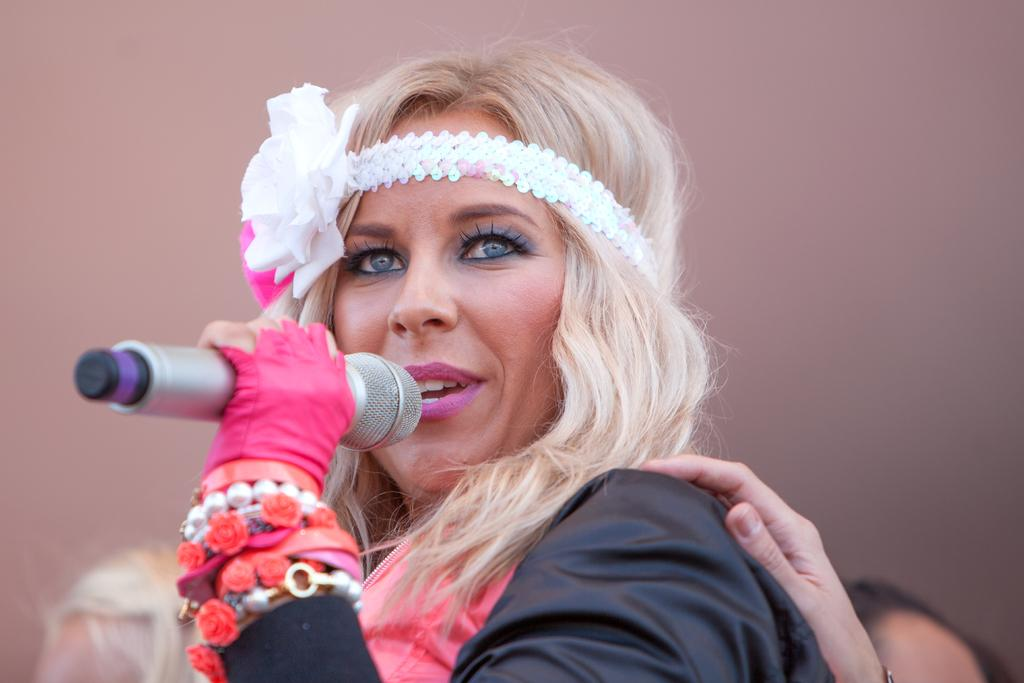What is the main subject of the image? There is a woman in the image. What is the woman doing in the image? The woman is singing. What object is the woman holding in her hand? The woman is holding a microphone in her hand. What accessory is the woman wearing on her head? The woman is wearing a hair band. What type of jewelry is the woman wearing on her hand? The woman has chains on her hand. What type of glove is the woman wearing on her foot in the image? There is no glove visible on the woman's foot in the image. 